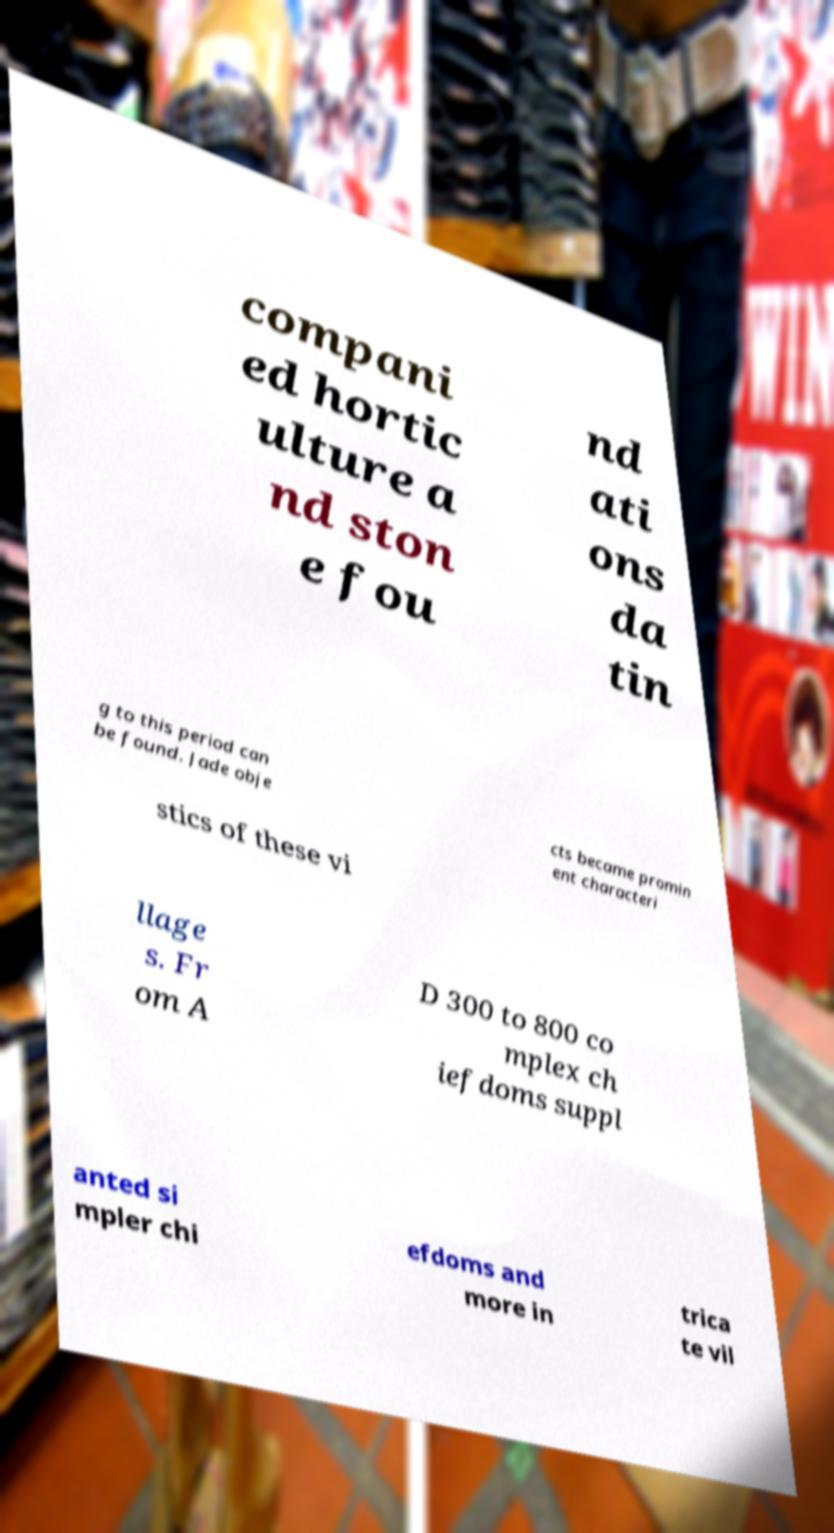Please identify and transcribe the text found in this image. compani ed hortic ulture a nd ston e fou nd ati ons da tin g to this period can be found. Jade obje cts became promin ent characteri stics of these vi llage s. Fr om A D 300 to 800 co mplex ch iefdoms suppl anted si mpler chi efdoms and more in trica te vil 